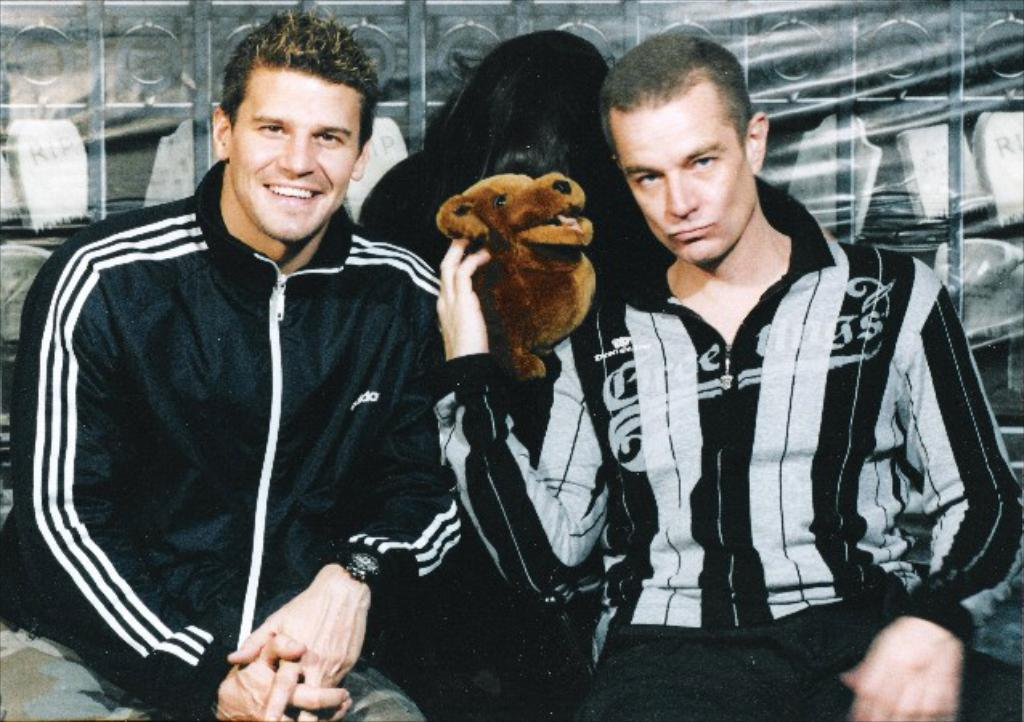How many people are in the image? There are two persons in the image. What are the persons doing in the image? The persons are sitting. What are the persons holding in the image? The persons are holding a dog. Where is the kettle located in the image? There is no kettle present in the image. What type of muscle is visible on the dog in the image? There is no dog muscle visible in the image, as the dog is being held by the persons. 